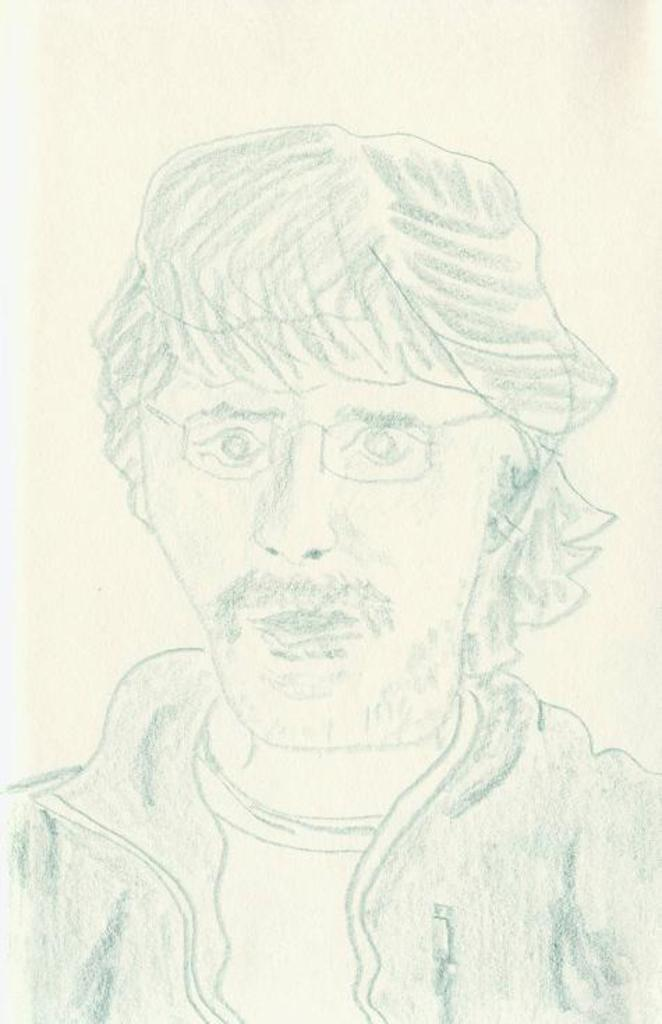What is depicted in the image? There is a drawing of a person in the image. What type of bath is the person taking in the image? There is no bath present in the image, as it only features a drawing of a person. What guide is the person using in the image? There is no guide present in the image, as it only features a drawing of a person. 